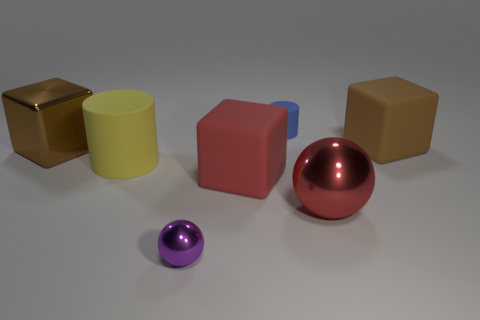Is there anything else that is made of the same material as the purple sphere?
Keep it short and to the point. Yes. What number of other tiny blue things are the same shape as the small blue thing?
Provide a short and direct response. 0. What is the size of the red thing that is made of the same material as the tiny ball?
Your response must be concise. Large. Is there a thing to the left of the small thing that is behind the cube that is on the left side of the big red rubber cube?
Your answer should be compact. Yes. There is a brown cube that is to the right of the purple sphere; does it have the same size as the purple shiny thing?
Your answer should be very brief. No. How many blue cylinders have the same size as the purple sphere?
Your response must be concise. 1. What size is the matte block that is the same color as the metal block?
Your answer should be very brief. Large. Is the big metal sphere the same color as the tiny metal ball?
Provide a succinct answer. No. What is the shape of the red matte thing?
Keep it short and to the point. Cube. Is there a metallic ball that has the same color as the small matte cylinder?
Keep it short and to the point. No. 